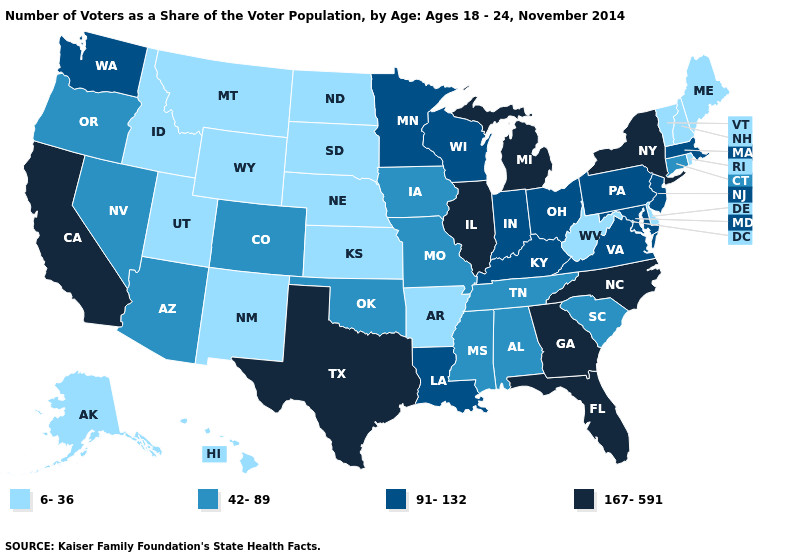Name the states that have a value in the range 167-591?
Write a very short answer. California, Florida, Georgia, Illinois, Michigan, New York, North Carolina, Texas. What is the highest value in states that border Texas?
Answer briefly. 91-132. What is the highest value in states that border Massachusetts?
Write a very short answer. 167-591. Does Arkansas have the lowest value in the USA?
Answer briefly. Yes. What is the highest value in the USA?
Give a very brief answer. 167-591. What is the value of Maryland?
Give a very brief answer. 91-132. Does Pennsylvania have a lower value than Illinois?
Give a very brief answer. Yes. What is the highest value in states that border Wyoming?
Answer briefly. 42-89. What is the value of Georgia?
Keep it brief. 167-591. What is the value of Indiana?
Quick response, please. 91-132. What is the value of Oregon?
Quick response, please. 42-89. How many symbols are there in the legend?
Answer briefly. 4. What is the highest value in the South ?
Answer briefly. 167-591. Does Indiana have a lower value than Texas?
Give a very brief answer. Yes. What is the value of Utah?
Quick response, please. 6-36. 